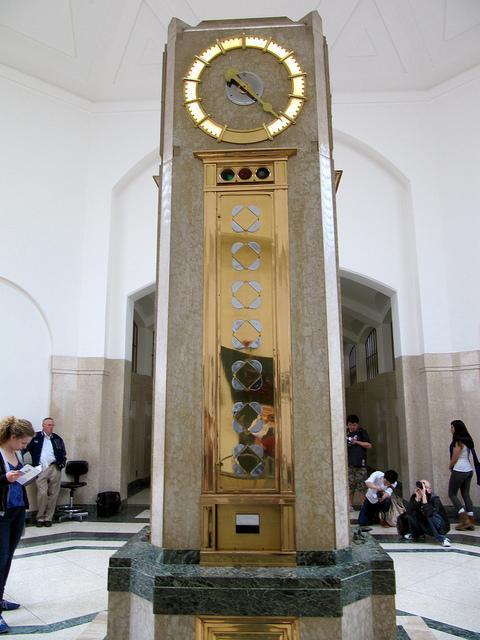How many people are visible?
Give a very brief answer. 2. 